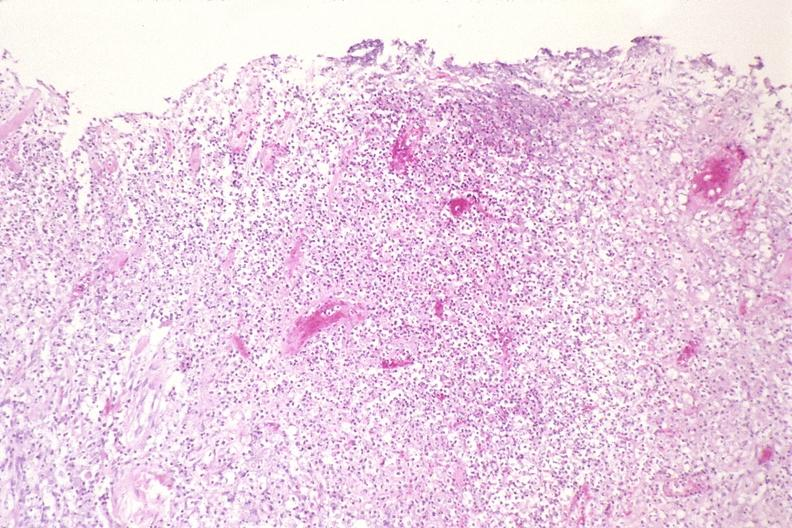does this image show lung, histoplasma pneumonia?
Answer the question using a single word or phrase. Yes 